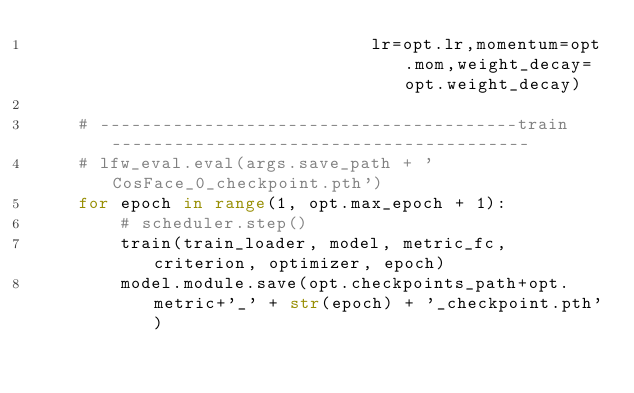<code> <loc_0><loc_0><loc_500><loc_500><_Python_>                                lr=opt.lr,momentum=opt.mom,weight_decay=opt.weight_decay)

    # ----------------------------------------train----------------------------------------
    # lfw_eval.eval(args.save_path + 'CosFace_0_checkpoint.pth')
    for epoch in range(1, opt.max_epoch + 1):
        # scheduler.step()
        train(train_loader, model, metric_fc, criterion, optimizer, epoch)
        model.module.save(opt.checkpoints_path+opt.metric+'_' + str(epoch) + '_checkpoint.pth')</code> 